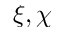Convert formula to latex. <formula><loc_0><loc_0><loc_500><loc_500>\xi , \chi</formula> 